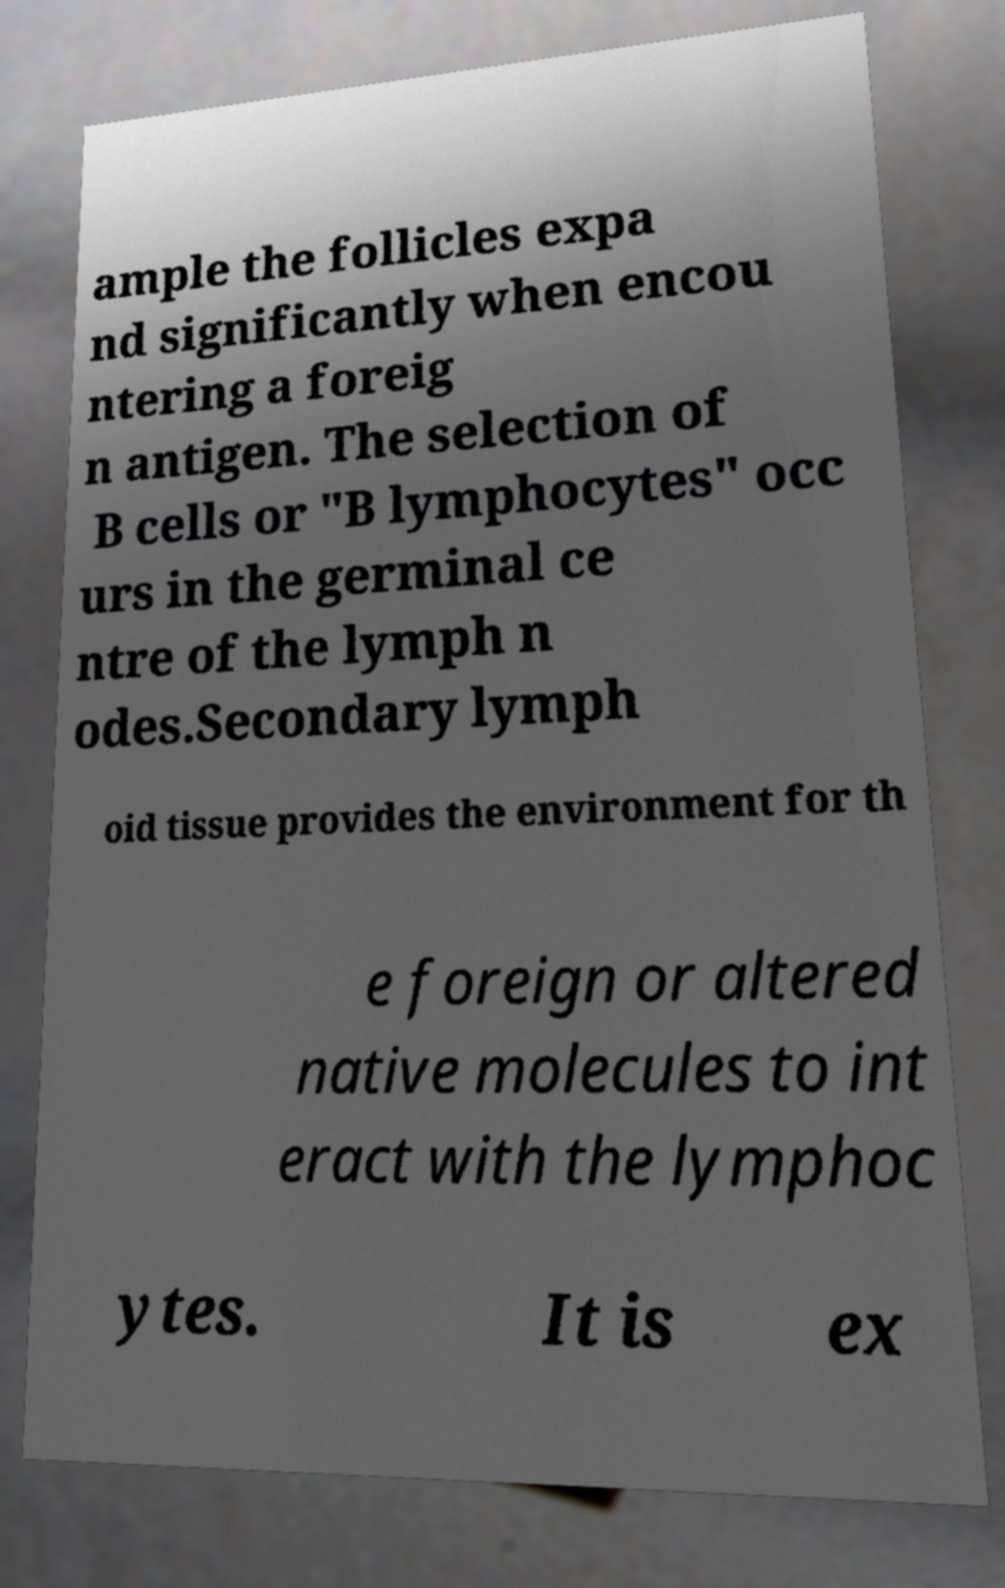Can you accurately transcribe the text from the provided image for me? ample the follicles expa nd significantly when encou ntering a foreig n antigen. The selection of B cells or "B lymphocytes" occ urs in the germinal ce ntre of the lymph n odes.Secondary lymph oid tissue provides the environment for th e foreign or altered native molecules to int eract with the lymphoc ytes. It is ex 